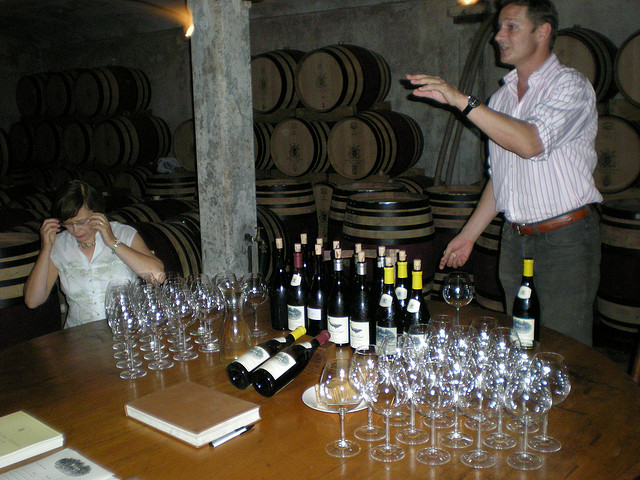What can the layout and settings of this wine tasting event suggest about the winery's visitor experience? The careful arrangement of numerous wine glasses and open bottles ready for tasting implies a well-organized event, catering to an audience interested in learning about wine. The setting in the cellar, amidst the barrels, suggests an immersive experience, likely designed to educate guests on the wine production process and the subtleties of flavor developed through aging in oak barrels. 